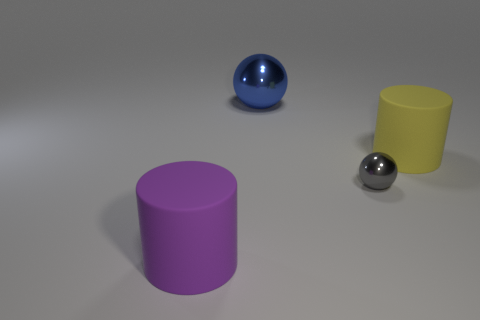Add 3 tiny gray balls. How many objects exist? 7 Subtract 1 yellow cylinders. How many objects are left? 3 Subtract all tiny red balls. Subtract all large yellow things. How many objects are left? 3 Add 1 big shiny balls. How many big shiny balls are left? 2 Add 1 gray matte balls. How many gray matte balls exist? 1 